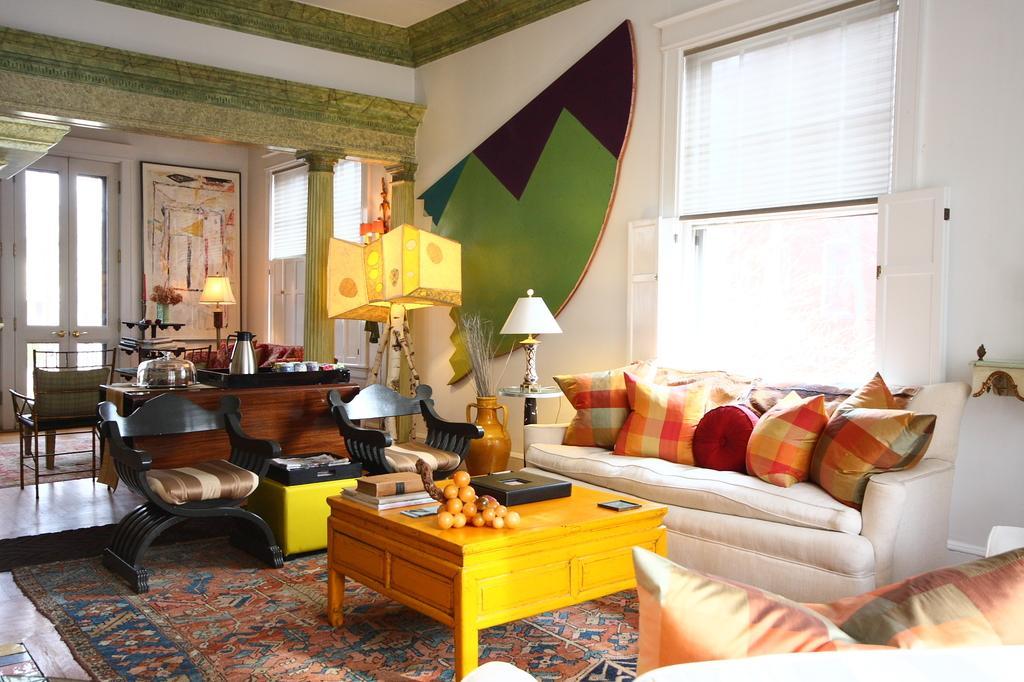Describe this image in one or two sentences. The photo is clicked inside a room. In the room there are sofa set, chairs, table on the table there are books, statues, flower pot. On the side tables there are lamps. There is a window over here ,on the floor there is carpet. There is a portrait over here, there are doors over here. On a tray there are jug, cups. 